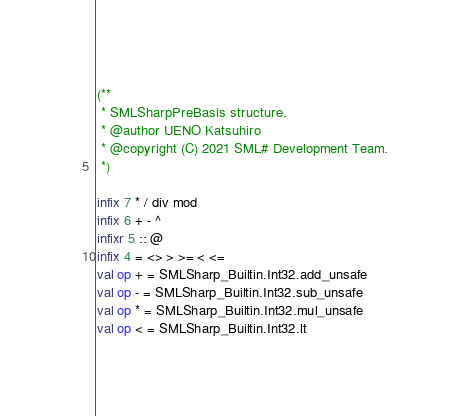Convert code to text. <code><loc_0><loc_0><loc_500><loc_500><_SML_>(**
 * SMLSharpPreBasis structure.
 * @author UENO Katsuhiro
 * @copyright (C) 2021 SML# Development Team.
 *)

infix 7 * / div mod
infix 6 + - ^
infixr 5 :: @
infix 4 = <> > >= < <=
val op + = SMLSharp_Builtin.Int32.add_unsafe
val op - = SMLSharp_Builtin.Int32.sub_unsafe
val op * = SMLSharp_Builtin.Int32.mul_unsafe
val op < = SMLSharp_Builtin.Int32.lt</code> 